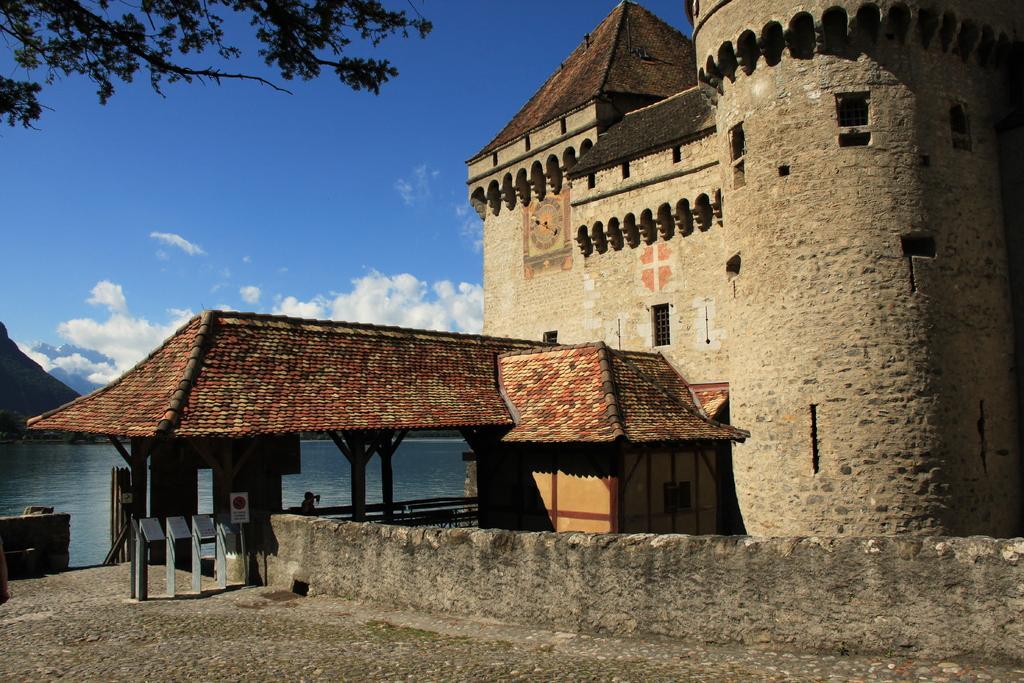How would you summarize this image in a sentence or two? In this image there is a shed with a red color roof on the left side. There is a tree on the left side. There is a stone building on the building. There are clouds in the sky. 